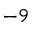<formula> <loc_0><loc_0><loc_500><loc_500>^ { - 9 }</formula> 